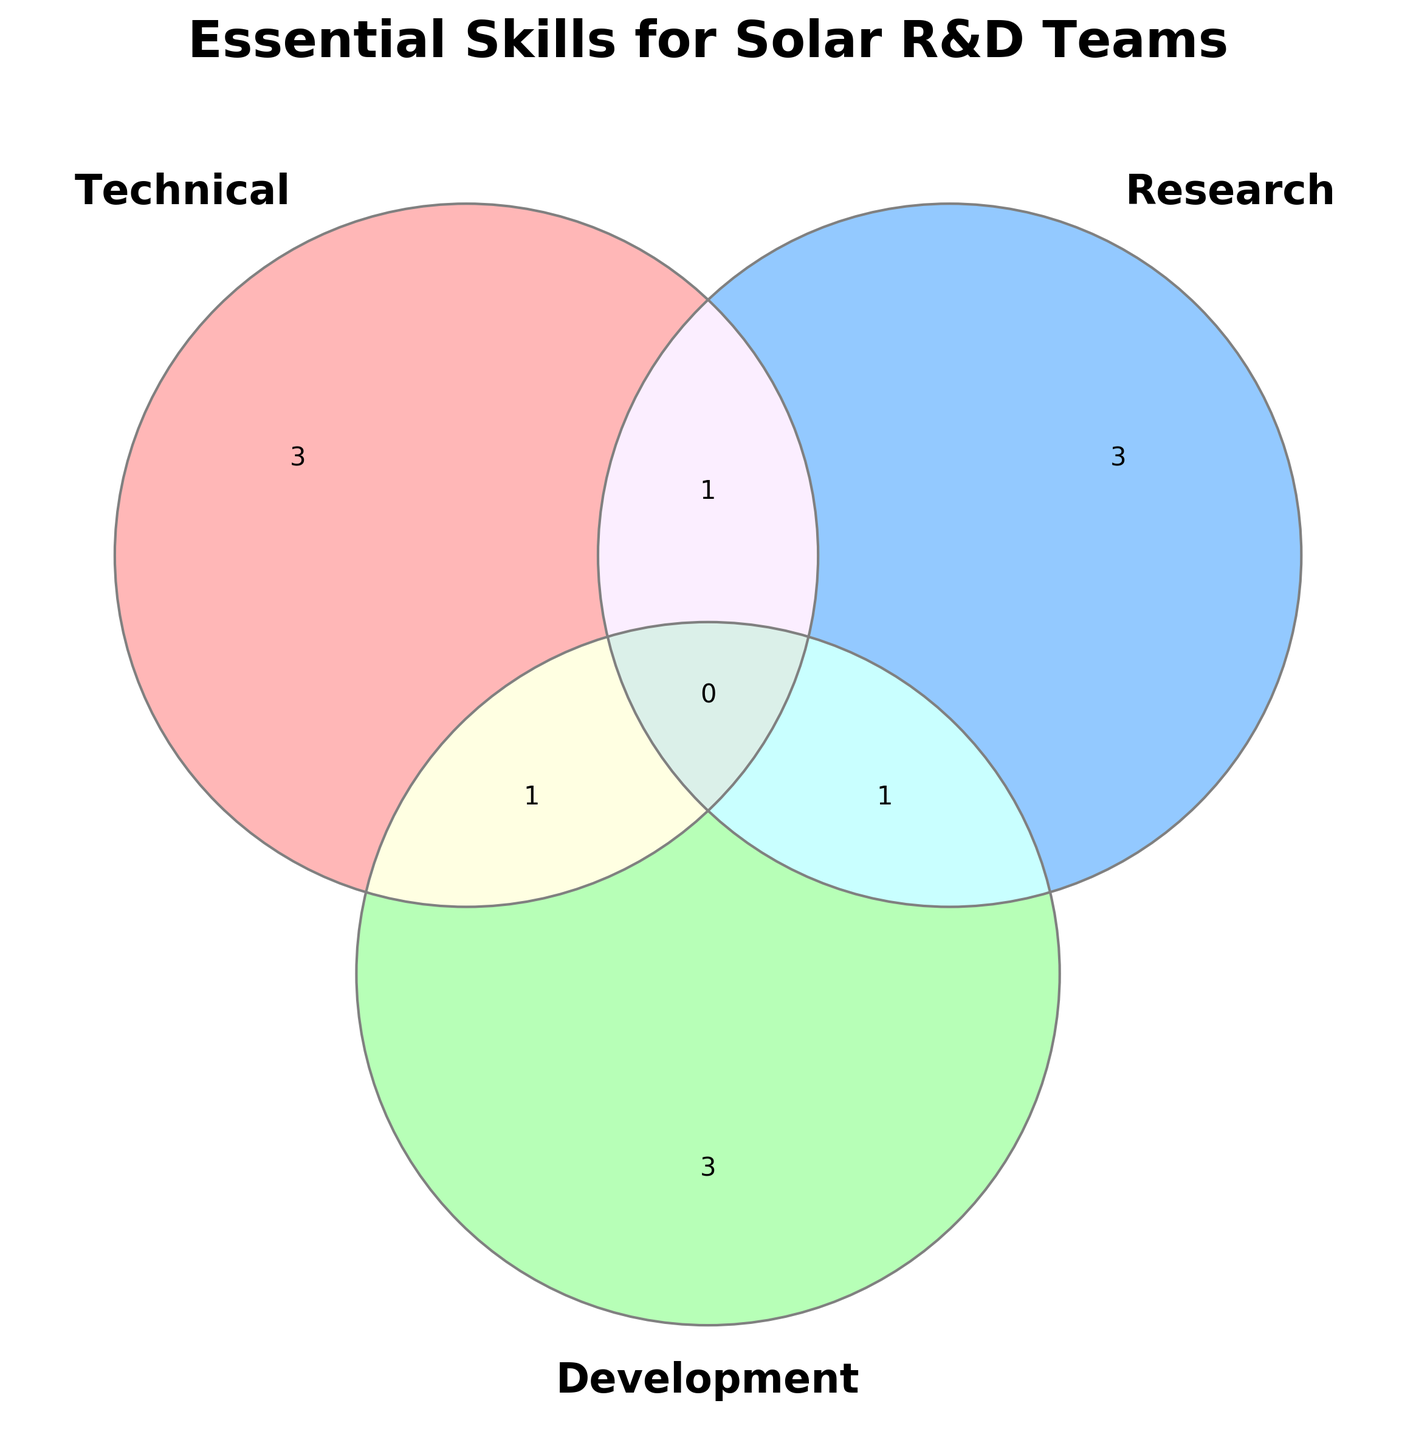What is the title of the plotted figure? The title is displayed at the top of the Venn diagram, formatted in bold and large font size. It reads "Essential Skills for Solar R&D Teams".
Answer: Essential Skills for Solar R&D Teams How many skill categories are represented in the Venn diagram? The Venn diagram includes three categories as indicated by the three labeled circles. These labels are "Technical", "Research", and "Development".
Answer: Three What skill is shared between the 'Technical' and 'Research' categories? By looking at the section where the circles for 'Technical' and 'Research' overlap, but not 'Development', we see the skill 'Solar Cell Efficiency'.
Answer: Solar Cell Efficiency Which skill is unique to the 'Development' category? By analyzing the part of the 'Development' circle that does not overlap with any other circle, we see 'Project Management', 'Prototyping', and 'Software Development' listed in this space.
Answer: Project Management, Prototyping, Software Development What skill is common to all three categories? The central intersection where all three circles overlap contains the shared skill across 'Technical', 'Research', and 'Development', which is 'System Integration'.
Answer: System Integration Which category has the most unique skills? We count the skills in the sections of each circle that do not overlap with others. 'Technical' has 3 unique skills, 'Research' has 3, and 'Development' has 3. Thus, all categories have an equal number of unique skills.
Answer: All categories have equal unique skills What skill is shared between 'Research' and 'Development' but not 'Technical'? The overlapping section between 'Research' and 'Development' circles, excluding 'Technical', shows the skill 'Innovation Strategy'.
Answer: Innovation Strategy How many skills in total are represented in the Venn diagram? Adding up the unique skills (3 from Technical, 3 from Research, 3 from Development) and the shared skills (1 from Technical-Research, 1 from Technical-Development, 1 from Research-Development, and 1 from all three categories) gives a total of 10 individual skills plus shared ones. So 11 skills total.
Answer: Eleven Which two skills are found exclusively in the 'Technical-Development' intersection? By focusing on the intersection of 'Technical' and 'Development' only, we observe the skills 'System Integration' and no other respective to the 'Technical-Research' specific intersection.
Answer: System Integration 